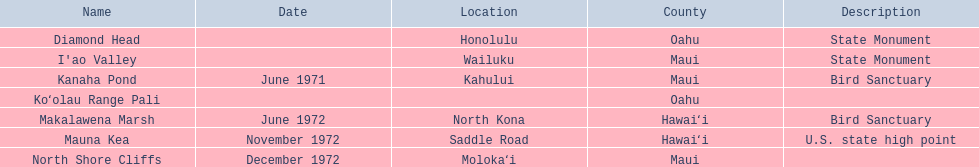What are all the landmark names? Diamond Head, I'ao Valley, Kanaha Pond, Koʻolau Range Pali, Makalawena Marsh, Mauna Kea, North Shore Cliffs. Which county is each landlord in? Oahu, Maui, Maui, Oahu, Hawaiʻi, Hawaiʻi, Maui. Along with mauna kea, which landmark is in hawai'i county? Makalawena Marsh. 